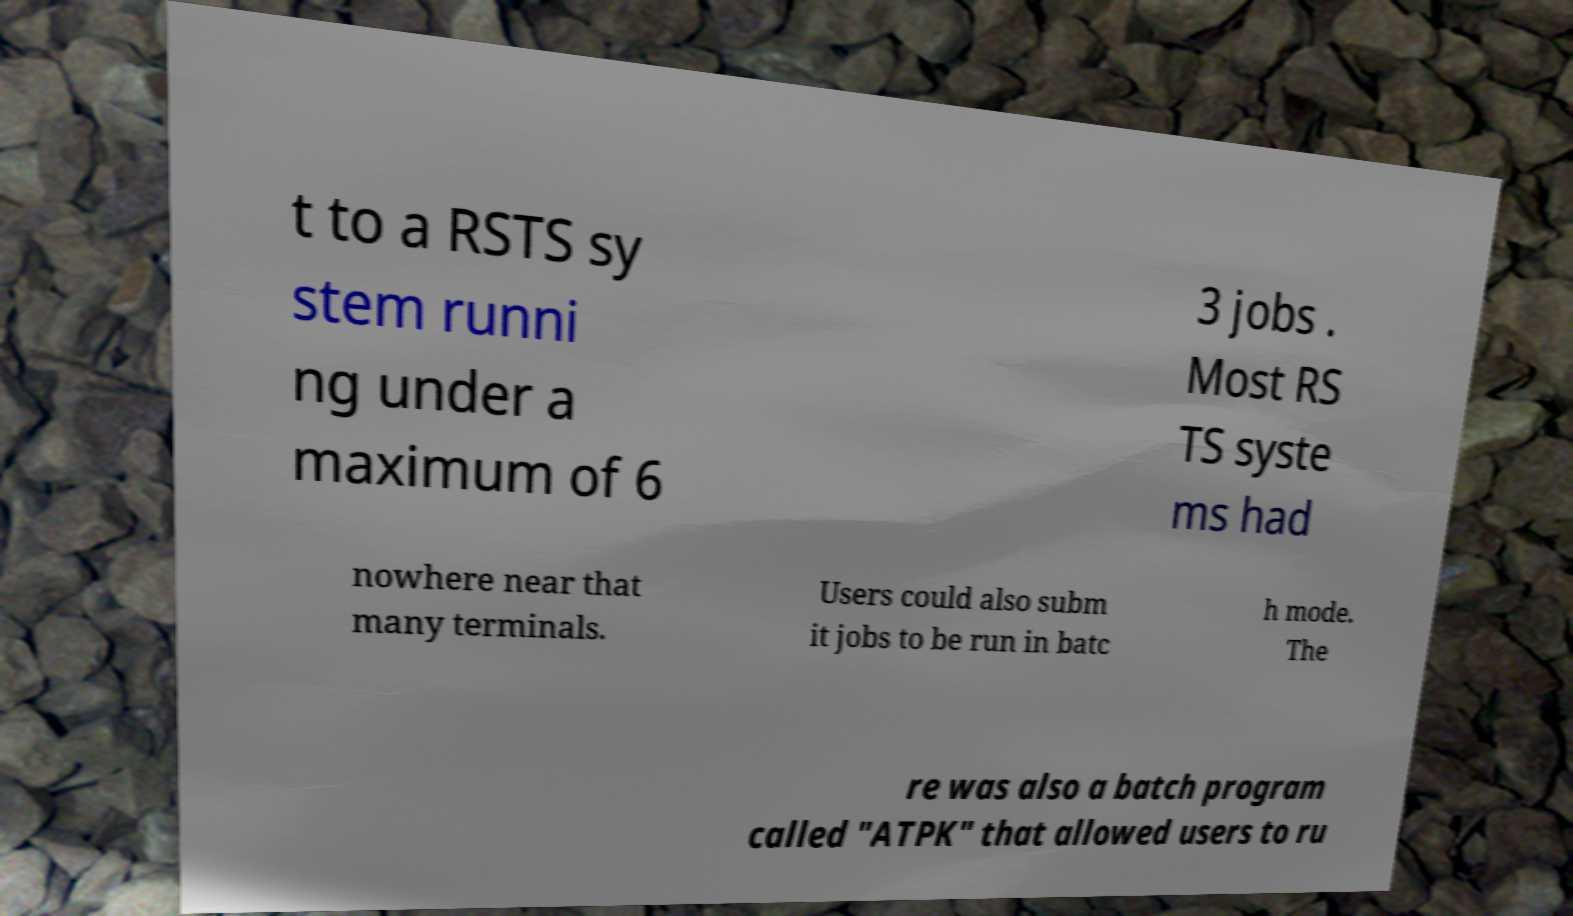For documentation purposes, I need the text within this image transcribed. Could you provide that? t to a RSTS sy stem runni ng under a maximum of 6 3 jobs . Most RS TS syste ms had nowhere near that many terminals. Users could also subm it jobs to be run in batc h mode. The re was also a batch program called "ATPK" that allowed users to ru 